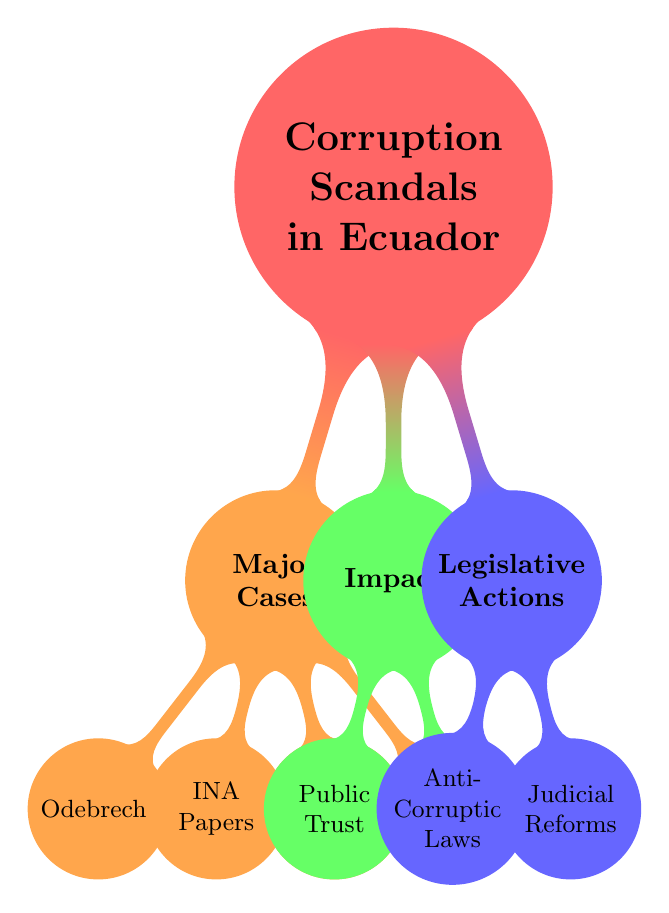What are the four major cases of corruption scandals in Ecuador? The diagram lists four major cases under the "Major Cases" node: Odebrecht, INA Papers, Petroecuador, and Los Fefer.
Answer: Odebrecht, INA Papers, Petroecuador, Los Fefer Who is a key figure associated with the Odebrecht scandal? The diagram specifies Jorge Glas (Vice President) and Rafael Correa (Former President) as key figures in the Odebrecht case. Since the question asks for one, I'll state Jorge Glas.
Answer: Jorge Glas What is the current status of the investigation into the INA Papers? The "INA Papers" node states that the investigation is ongoing, with public outrage also noted in the impact section.
Answer: Ongoing What is the outcome of the Petroecuador scandal? The Petroecuador node mentions arrests and convictions as well as major financial losses resulting from the scandal.
Answer: Arrests and convictions, major financial losses What is the status of public trust in Ecuador due to these corruption scandals? In the "Impact" section under "Public Trust," it is stated that trust has been severely eroded due to these scandals.
Answer: Severely Eroded What changes occurred in the political landscape as a result of the scandals? The diagram's "Political Landscape" node lists shifts in party power and increased calls for transparency and reform as changes that occurred.
Answer: Shifts in party power, increased calls for transparency and reform What legislative actions are proposed to combat corruption according to the diagram? The diagram outlines legislative actions, specifically mentioning two types: Anti-Corruption Laws and Judicial Reforms.
Answer: Anti-Corruption Laws, Judicial Reforms How many major cases are detailed in the mind map? The "Major Cases" node lists four cases, which directly answers the question.
Answer: Four What has been the public response to these corruption scandals? The "Impact" section under "Public Trust" indicates that there have been protests and media scrutiny as part of the public response.
Answer: Protests and media scrutiny 